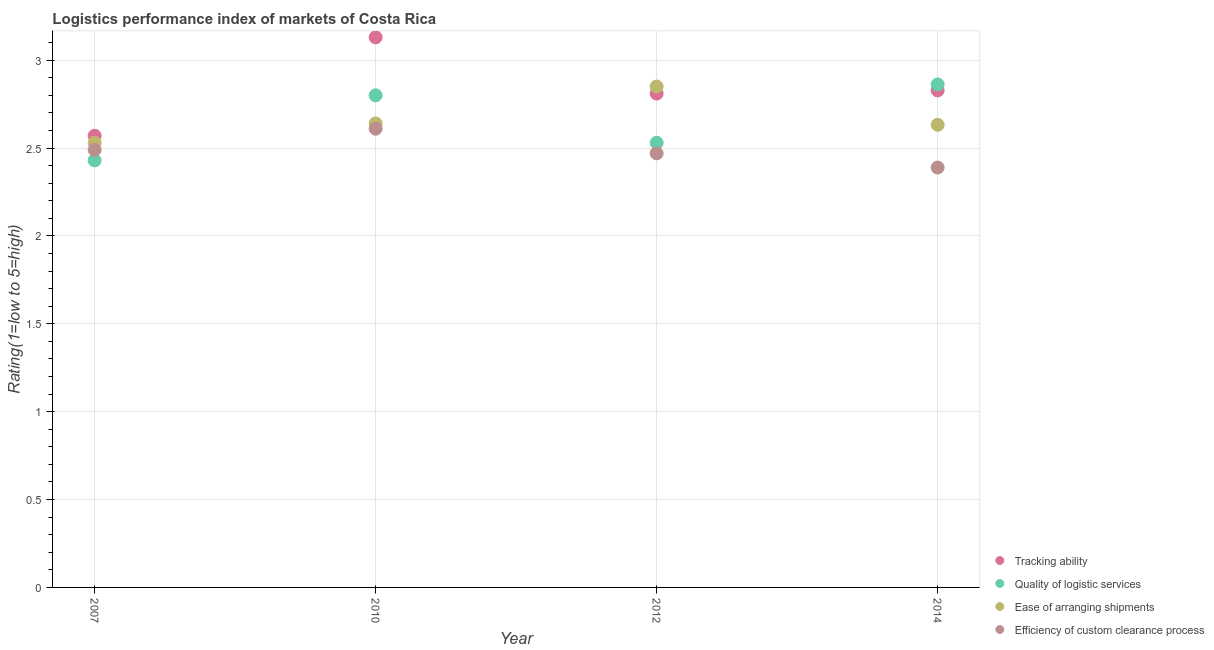What is the lpi rating of tracking ability in 2014?
Give a very brief answer. 2.83. Across all years, what is the maximum lpi rating of quality of logistic services?
Ensure brevity in your answer.  2.86. Across all years, what is the minimum lpi rating of quality of logistic services?
Provide a short and direct response. 2.43. In which year was the lpi rating of tracking ability maximum?
Offer a terse response. 2010. What is the total lpi rating of efficiency of custom clearance process in the graph?
Make the answer very short. 9.96. What is the difference between the lpi rating of efficiency of custom clearance process in 2007 and that in 2010?
Offer a terse response. -0.12. What is the difference between the lpi rating of quality of logistic services in 2010 and the lpi rating of efficiency of custom clearance process in 2014?
Provide a succinct answer. 0.41. What is the average lpi rating of efficiency of custom clearance process per year?
Offer a terse response. 2.49. In the year 2014, what is the difference between the lpi rating of tracking ability and lpi rating of ease of arranging shipments?
Give a very brief answer. 0.2. In how many years, is the lpi rating of tracking ability greater than 1?
Your answer should be compact. 4. What is the ratio of the lpi rating of efficiency of custom clearance process in 2007 to that in 2012?
Ensure brevity in your answer.  1.01. Is the lpi rating of quality of logistic services in 2012 less than that in 2014?
Ensure brevity in your answer.  Yes. What is the difference between the highest and the second highest lpi rating of tracking ability?
Your answer should be compact. 0.3. What is the difference between the highest and the lowest lpi rating of quality of logistic services?
Offer a very short reply. 0.43. Is the lpi rating of tracking ability strictly greater than the lpi rating of ease of arranging shipments over the years?
Offer a very short reply. No. How many dotlines are there?
Keep it short and to the point. 4. How many years are there in the graph?
Keep it short and to the point. 4. What is the difference between two consecutive major ticks on the Y-axis?
Your response must be concise. 0.5. Are the values on the major ticks of Y-axis written in scientific E-notation?
Give a very brief answer. No. Does the graph contain any zero values?
Make the answer very short. No. Where does the legend appear in the graph?
Your answer should be very brief. Bottom right. What is the title of the graph?
Your answer should be compact. Logistics performance index of markets of Costa Rica. What is the label or title of the Y-axis?
Offer a very short reply. Rating(1=low to 5=high). What is the Rating(1=low to 5=high) in Tracking ability in 2007?
Provide a short and direct response. 2.57. What is the Rating(1=low to 5=high) in Quality of logistic services in 2007?
Offer a very short reply. 2.43. What is the Rating(1=low to 5=high) of Ease of arranging shipments in 2007?
Keep it short and to the point. 2.53. What is the Rating(1=low to 5=high) of Efficiency of custom clearance process in 2007?
Your response must be concise. 2.49. What is the Rating(1=low to 5=high) in Tracking ability in 2010?
Your response must be concise. 3.13. What is the Rating(1=low to 5=high) in Ease of arranging shipments in 2010?
Your answer should be compact. 2.64. What is the Rating(1=low to 5=high) in Efficiency of custom clearance process in 2010?
Offer a terse response. 2.61. What is the Rating(1=low to 5=high) of Tracking ability in 2012?
Provide a succinct answer. 2.81. What is the Rating(1=low to 5=high) in Quality of logistic services in 2012?
Provide a succinct answer. 2.53. What is the Rating(1=low to 5=high) of Ease of arranging shipments in 2012?
Offer a very short reply. 2.85. What is the Rating(1=low to 5=high) of Efficiency of custom clearance process in 2012?
Offer a terse response. 2.47. What is the Rating(1=low to 5=high) of Tracking ability in 2014?
Keep it short and to the point. 2.83. What is the Rating(1=low to 5=high) in Quality of logistic services in 2014?
Offer a terse response. 2.86. What is the Rating(1=low to 5=high) of Ease of arranging shipments in 2014?
Your answer should be compact. 2.63. What is the Rating(1=low to 5=high) in Efficiency of custom clearance process in 2014?
Offer a terse response. 2.39. Across all years, what is the maximum Rating(1=low to 5=high) in Tracking ability?
Provide a short and direct response. 3.13. Across all years, what is the maximum Rating(1=low to 5=high) in Quality of logistic services?
Your answer should be compact. 2.86. Across all years, what is the maximum Rating(1=low to 5=high) in Ease of arranging shipments?
Offer a terse response. 2.85. Across all years, what is the maximum Rating(1=low to 5=high) in Efficiency of custom clearance process?
Your answer should be compact. 2.61. Across all years, what is the minimum Rating(1=low to 5=high) in Tracking ability?
Ensure brevity in your answer.  2.57. Across all years, what is the minimum Rating(1=low to 5=high) in Quality of logistic services?
Your answer should be compact. 2.43. Across all years, what is the minimum Rating(1=low to 5=high) in Ease of arranging shipments?
Your answer should be compact. 2.53. Across all years, what is the minimum Rating(1=low to 5=high) of Efficiency of custom clearance process?
Provide a succinct answer. 2.39. What is the total Rating(1=low to 5=high) in Tracking ability in the graph?
Make the answer very short. 11.34. What is the total Rating(1=low to 5=high) of Quality of logistic services in the graph?
Your answer should be very brief. 10.62. What is the total Rating(1=low to 5=high) of Ease of arranging shipments in the graph?
Offer a terse response. 10.65. What is the total Rating(1=low to 5=high) in Efficiency of custom clearance process in the graph?
Keep it short and to the point. 9.96. What is the difference between the Rating(1=low to 5=high) in Tracking ability in 2007 and that in 2010?
Provide a succinct answer. -0.56. What is the difference between the Rating(1=low to 5=high) in Quality of logistic services in 2007 and that in 2010?
Make the answer very short. -0.37. What is the difference between the Rating(1=low to 5=high) of Ease of arranging shipments in 2007 and that in 2010?
Offer a very short reply. -0.11. What is the difference between the Rating(1=low to 5=high) of Efficiency of custom clearance process in 2007 and that in 2010?
Keep it short and to the point. -0.12. What is the difference between the Rating(1=low to 5=high) in Tracking ability in 2007 and that in 2012?
Your response must be concise. -0.24. What is the difference between the Rating(1=low to 5=high) of Ease of arranging shipments in 2007 and that in 2012?
Give a very brief answer. -0.32. What is the difference between the Rating(1=low to 5=high) of Tracking ability in 2007 and that in 2014?
Make the answer very short. -0.26. What is the difference between the Rating(1=low to 5=high) in Quality of logistic services in 2007 and that in 2014?
Ensure brevity in your answer.  -0.43. What is the difference between the Rating(1=low to 5=high) in Ease of arranging shipments in 2007 and that in 2014?
Make the answer very short. -0.1. What is the difference between the Rating(1=low to 5=high) of Efficiency of custom clearance process in 2007 and that in 2014?
Provide a short and direct response. 0.1. What is the difference between the Rating(1=low to 5=high) of Tracking ability in 2010 and that in 2012?
Make the answer very short. 0.32. What is the difference between the Rating(1=low to 5=high) of Quality of logistic services in 2010 and that in 2012?
Offer a very short reply. 0.27. What is the difference between the Rating(1=low to 5=high) of Ease of arranging shipments in 2010 and that in 2012?
Your answer should be very brief. -0.21. What is the difference between the Rating(1=low to 5=high) in Efficiency of custom clearance process in 2010 and that in 2012?
Offer a very short reply. 0.14. What is the difference between the Rating(1=low to 5=high) of Tracking ability in 2010 and that in 2014?
Your response must be concise. 0.3. What is the difference between the Rating(1=low to 5=high) in Quality of logistic services in 2010 and that in 2014?
Your answer should be very brief. -0.06. What is the difference between the Rating(1=low to 5=high) of Ease of arranging shipments in 2010 and that in 2014?
Your answer should be very brief. 0.01. What is the difference between the Rating(1=low to 5=high) of Efficiency of custom clearance process in 2010 and that in 2014?
Offer a very short reply. 0.22. What is the difference between the Rating(1=low to 5=high) of Tracking ability in 2012 and that in 2014?
Give a very brief answer. -0.02. What is the difference between the Rating(1=low to 5=high) in Quality of logistic services in 2012 and that in 2014?
Offer a terse response. -0.33. What is the difference between the Rating(1=low to 5=high) in Ease of arranging shipments in 2012 and that in 2014?
Your answer should be compact. 0.22. What is the difference between the Rating(1=low to 5=high) in Efficiency of custom clearance process in 2012 and that in 2014?
Your answer should be compact. 0.08. What is the difference between the Rating(1=low to 5=high) in Tracking ability in 2007 and the Rating(1=low to 5=high) in Quality of logistic services in 2010?
Your answer should be very brief. -0.23. What is the difference between the Rating(1=low to 5=high) of Tracking ability in 2007 and the Rating(1=low to 5=high) of Ease of arranging shipments in 2010?
Make the answer very short. -0.07. What is the difference between the Rating(1=low to 5=high) of Tracking ability in 2007 and the Rating(1=low to 5=high) of Efficiency of custom clearance process in 2010?
Your answer should be compact. -0.04. What is the difference between the Rating(1=low to 5=high) of Quality of logistic services in 2007 and the Rating(1=low to 5=high) of Ease of arranging shipments in 2010?
Your answer should be very brief. -0.21. What is the difference between the Rating(1=low to 5=high) of Quality of logistic services in 2007 and the Rating(1=low to 5=high) of Efficiency of custom clearance process in 2010?
Give a very brief answer. -0.18. What is the difference between the Rating(1=low to 5=high) of Ease of arranging shipments in 2007 and the Rating(1=low to 5=high) of Efficiency of custom clearance process in 2010?
Your response must be concise. -0.08. What is the difference between the Rating(1=low to 5=high) in Tracking ability in 2007 and the Rating(1=low to 5=high) in Quality of logistic services in 2012?
Ensure brevity in your answer.  0.04. What is the difference between the Rating(1=low to 5=high) in Tracking ability in 2007 and the Rating(1=low to 5=high) in Ease of arranging shipments in 2012?
Your answer should be very brief. -0.28. What is the difference between the Rating(1=low to 5=high) in Tracking ability in 2007 and the Rating(1=low to 5=high) in Efficiency of custom clearance process in 2012?
Offer a terse response. 0.1. What is the difference between the Rating(1=low to 5=high) of Quality of logistic services in 2007 and the Rating(1=low to 5=high) of Ease of arranging shipments in 2012?
Give a very brief answer. -0.42. What is the difference between the Rating(1=low to 5=high) of Quality of logistic services in 2007 and the Rating(1=low to 5=high) of Efficiency of custom clearance process in 2012?
Ensure brevity in your answer.  -0.04. What is the difference between the Rating(1=low to 5=high) in Ease of arranging shipments in 2007 and the Rating(1=low to 5=high) in Efficiency of custom clearance process in 2012?
Offer a very short reply. 0.06. What is the difference between the Rating(1=low to 5=high) in Tracking ability in 2007 and the Rating(1=low to 5=high) in Quality of logistic services in 2014?
Make the answer very short. -0.29. What is the difference between the Rating(1=low to 5=high) in Tracking ability in 2007 and the Rating(1=low to 5=high) in Ease of arranging shipments in 2014?
Offer a very short reply. -0.06. What is the difference between the Rating(1=low to 5=high) in Tracking ability in 2007 and the Rating(1=low to 5=high) in Efficiency of custom clearance process in 2014?
Provide a succinct answer. 0.18. What is the difference between the Rating(1=low to 5=high) of Quality of logistic services in 2007 and the Rating(1=low to 5=high) of Ease of arranging shipments in 2014?
Give a very brief answer. -0.2. What is the difference between the Rating(1=low to 5=high) of Quality of logistic services in 2007 and the Rating(1=low to 5=high) of Efficiency of custom clearance process in 2014?
Give a very brief answer. 0.04. What is the difference between the Rating(1=low to 5=high) in Ease of arranging shipments in 2007 and the Rating(1=low to 5=high) in Efficiency of custom clearance process in 2014?
Offer a terse response. 0.14. What is the difference between the Rating(1=low to 5=high) of Tracking ability in 2010 and the Rating(1=low to 5=high) of Quality of logistic services in 2012?
Your answer should be compact. 0.6. What is the difference between the Rating(1=low to 5=high) in Tracking ability in 2010 and the Rating(1=low to 5=high) in Ease of arranging shipments in 2012?
Your answer should be very brief. 0.28. What is the difference between the Rating(1=low to 5=high) of Tracking ability in 2010 and the Rating(1=low to 5=high) of Efficiency of custom clearance process in 2012?
Provide a succinct answer. 0.66. What is the difference between the Rating(1=low to 5=high) of Quality of logistic services in 2010 and the Rating(1=low to 5=high) of Efficiency of custom clearance process in 2012?
Provide a succinct answer. 0.33. What is the difference between the Rating(1=low to 5=high) in Ease of arranging shipments in 2010 and the Rating(1=low to 5=high) in Efficiency of custom clearance process in 2012?
Provide a short and direct response. 0.17. What is the difference between the Rating(1=low to 5=high) in Tracking ability in 2010 and the Rating(1=low to 5=high) in Quality of logistic services in 2014?
Offer a very short reply. 0.27. What is the difference between the Rating(1=low to 5=high) of Tracking ability in 2010 and the Rating(1=low to 5=high) of Ease of arranging shipments in 2014?
Offer a terse response. 0.5. What is the difference between the Rating(1=low to 5=high) of Tracking ability in 2010 and the Rating(1=low to 5=high) of Efficiency of custom clearance process in 2014?
Give a very brief answer. 0.74. What is the difference between the Rating(1=low to 5=high) of Quality of logistic services in 2010 and the Rating(1=low to 5=high) of Ease of arranging shipments in 2014?
Keep it short and to the point. 0.17. What is the difference between the Rating(1=low to 5=high) of Quality of logistic services in 2010 and the Rating(1=low to 5=high) of Efficiency of custom clearance process in 2014?
Keep it short and to the point. 0.41. What is the difference between the Rating(1=low to 5=high) in Ease of arranging shipments in 2010 and the Rating(1=low to 5=high) in Efficiency of custom clearance process in 2014?
Give a very brief answer. 0.25. What is the difference between the Rating(1=low to 5=high) of Tracking ability in 2012 and the Rating(1=low to 5=high) of Quality of logistic services in 2014?
Provide a short and direct response. -0.05. What is the difference between the Rating(1=low to 5=high) of Tracking ability in 2012 and the Rating(1=low to 5=high) of Ease of arranging shipments in 2014?
Offer a very short reply. 0.18. What is the difference between the Rating(1=low to 5=high) of Tracking ability in 2012 and the Rating(1=low to 5=high) of Efficiency of custom clearance process in 2014?
Offer a very short reply. 0.42. What is the difference between the Rating(1=low to 5=high) of Quality of logistic services in 2012 and the Rating(1=low to 5=high) of Ease of arranging shipments in 2014?
Provide a short and direct response. -0.1. What is the difference between the Rating(1=low to 5=high) of Quality of logistic services in 2012 and the Rating(1=low to 5=high) of Efficiency of custom clearance process in 2014?
Your answer should be compact. 0.14. What is the difference between the Rating(1=low to 5=high) in Ease of arranging shipments in 2012 and the Rating(1=low to 5=high) in Efficiency of custom clearance process in 2014?
Give a very brief answer. 0.46. What is the average Rating(1=low to 5=high) in Tracking ability per year?
Provide a short and direct response. 2.83. What is the average Rating(1=low to 5=high) in Quality of logistic services per year?
Your response must be concise. 2.66. What is the average Rating(1=low to 5=high) of Ease of arranging shipments per year?
Your response must be concise. 2.66. What is the average Rating(1=low to 5=high) in Efficiency of custom clearance process per year?
Your response must be concise. 2.49. In the year 2007, what is the difference between the Rating(1=low to 5=high) in Tracking ability and Rating(1=low to 5=high) in Quality of logistic services?
Your answer should be very brief. 0.14. In the year 2007, what is the difference between the Rating(1=low to 5=high) of Quality of logistic services and Rating(1=low to 5=high) of Ease of arranging shipments?
Keep it short and to the point. -0.1. In the year 2007, what is the difference between the Rating(1=low to 5=high) in Quality of logistic services and Rating(1=low to 5=high) in Efficiency of custom clearance process?
Keep it short and to the point. -0.06. In the year 2010, what is the difference between the Rating(1=low to 5=high) of Tracking ability and Rating(1=low to 5=high) of Quality of logistic services?
Provide a succinct answer. 0.33. In the year 2010, what is the difference between the Rating(1=low to 5=high) in Tracking ability and Rating(1=low to 5=high) in Ease of arranging shipments?
Your response must be concise. 0.49. In the year 2010, what is the difference between the Rating(1=low to 5=high) of Tracking ability and Rating(1=low to 5=high) of Efficiency of custom clearance process?
Your answer should be compact. 0.52. In the year 2010, what is the difference between the Rating(1=low to 5=high) of Quality of logistic services and Rating(1=low to 5=high) of Ease of arranging shipments?
Provide a succinct answer. 0.16. In the year 2010, what is the difference between the Rating(1=low to 5=high) of Quality of logistic services and Rating(1=low to 5=high) of Efficiency of custom clearance process?
Your answer should be very brief. 0.19. In the year 2012, what is the difference between the Rating(1=low to 5=high) in Tracking ability and Rating(1=low to 5=high) in Quality of logistic services?
Make the answer very short. 0.28. In the year 2012, what is the difference between the Rating(1=low to 5=high) in Tracking ability and Rating(1=low to 5=high) in Ease of arranging shipments?
Offer a terse response. -0.04. In the year 2012, what is the difference between the Rating(1=low to 5=high) in Tracking ability and Rating(1=low to 5=high) in Efficiency of custom clearance process?
Offer a very short reply. 0.34. In the year 2012, what is the difference between the Rating(1=low to 5=high) of Quality of logistic services and Rating(1=low to 5=high) of Ease of arranging shipments?
Offer a terse response. -0.32. In the year 2012, what is the difference between the Rating(1=low to 5=high) in Ease of arranging shipments and Rating(1=low to 5=high) in Efficiency of custom clearance process?
Make the answer very short. 0.38. In the year 2014, what is the difference between the Rating(1=low to 5=high) of Tracking ability and Rating(1=low to 5=high) of Quality of logistic services?
Provide a succinct answer. -0.03. In the year 2014, what is the difference between the Rating(1=low to 5=high) in Tracking ability and Rating(1=low to 5=high) in Ease of arranging shipments?
Offer a terse response. 0.2. In the year 2014, what is the difference between the Rating(1=low to 5=high) of Tracking ability and Rating(1=low to 5=high) of Efficiency of custom clearance process?
Make the answer very short. 0.44. In the year 2014, what is the difference between the Rating(1=low to 5=high) of Quality of logistic services and Rating(1=low to 5=high) of Ease of arranging shipments?
Keep it short and to the point. 0.23. In the year 2014, what is the difference between the Rating(1=low to 5=high) in Quality of logistic services and Rating(1=low to 5=high) in Efficiency of custom clearance process?
Make the answer very short. 0.47. In the year 2014, what is the difference between the Rating(1=low to 5=high) of Ease of arranging shipments and Rating(1=low to 5=high) of Efficiency of custom clearance process?
Offer a very short reply. 0.24. What is the ratio of the Rating(1=low to 5=high) of Tracking ability in 2007 to that in 2010?
Offer a terse response. 0.82. What is the ratio of the Rating(1=low to 5=high) in Quality of logistic services in 2007 to that in 2010?
Provide a succinct answer. 0.87. What is the ratio of the Rating(1=low to 5=high) in Ease of arranging shipments in 2007 to that in 2010?
Provide a short and direct response. 0.96. What is the ratio of the Rating(1=low to 5=high) of Efficiency of custom clearance process in 2007 to that in 2010?
Offer a terse response. 0.95. What is the ratio of the Rating(1=low to 5=high) in Tracking ability in 2007 to that in 2012?
Keep it short and to the point. 0.91. What is the ratio of the Rating(1=low to 5=high) in Quality of logistic services in 2007 to that in 2012?
Give a very brief answer. 0.96. What is the ratio of the Rating(1=low to 5=high) in Ease of arranging shipments in 2007 to that in 2012?
Provide a succinct answer. 0.89. What is the ratio of the Rating(1=low to 5=high) of Tracking ability in 2007 to that in 2014?
Your answer should be very brief. 0.91. What is the ratio of the Rating(1=low to 5=high) of Quality of logistic services in 2007 to that in 2014?
Provide a succinct answer. 0.85. What is the ratio of the Rating(1=low to 5=high) in Ease of arranging shipments in 2007 to that in 2014?
Offer a terse response. 0.96. What is the ratio of the Rating(1=low to 5=high) of Efficiency of custom clearance process in 2007 to that in 2014?
Your answer should be compact. 1.04. What is the ratio of the Rating(1=low to 5=high) in Tracking ability in 2010 to that in 2012?
Your answer should be very brief. 1.11. What is the ratio of the Rating(1=low to 5=high) in Quality of logistic services in 2010 to that in 2012?
Give a very brief answer. 1.11. What is the ratio of the Rating(1=low to 5=high) of Ease of arranging shipments in 2010 to that in 2012?
Your response must be concise. 0.93. What is the ratio of the Rating(1=low to 5=high) of Efficiency of custom clearance process in 2010 to that in 2012?
Keep it short and to the point. 1.06. What is the ratio of the Rating(1=low to 5=high) in Tracking ability in 2010 to that in 2014?
Provide a short and direct response. 1.11. What is the ratio of the Rating(1=low to 5=high) in Quality of logistic services in 2010 to that in 2014?
Offer a terse response. 0.98. What is the ratio of the Rating(1=low to 5=high) in Ease of arranging shipments in 2010 to that in 2014?
Your response must be concise. 1. What is the ratio of the Rating(1=low to 5=high) in Efficiency of custom clearance process in 2010 to that in 2014?
Provide a short and direct response. 1.09. What is the ratio of the Rating(1=low to 5=high) in Tracking ability in 2012 to that in 2014?
Ensure brevity in your answer.  0.99. What is the ratio of the Rating(1=low to 5=high) in Quality of logistic services in 2012 to that in 2014?
Keep it short and to the point. 0.88. What is the ratio of the Rating(1=low to 5=high) in Ease of arranging shipments in 2012 to that in 2014?
Keep it short and to the point. 1.08. What is the ratio of the Rating(1=low to 5=high) in Efficiency of custom clearance process in 2012 to that in 2014?
Your response must be concise. 1.03. What is the difference between the highest and the second highest Rating(1=low to 5=high) of Tracking ability?
Ensure brevity in your answer.  0.3. What is the difference between the highest and the second highest Rating(1=low to 5=high) in Quality of logistic services?
Your response must be concise. 0.06. What is the difference between the highest and the second highest Rating(1=low to 5=high) in Ease of arranging shipments?
Offer a terse response. 0.21. What is the difference between the highest and the second highest Rating(1=low to 5=high) in Efficiency of custom clearance process?
Keep it short and to the point. 0.12. What is the difference between the highest and the lowest Rating(1=low to 5=high) in Tracking ability?
Provide a short and direct response. 0.56. What is the difference between the highest and the lowest Rating(1=low to 5=high) in Quality of logistic services?
Ensure brevity in your answer.  0.43. What is the difference between the highest and the lowest Rating(1=low to 5=high) of Ease of arranging shipments?
Offer a very short reply. 0.32. What is the difference between the highest and the lowest Rating(1=low to 5=high) of Efficiency of custom clearance process?
Provide a succinct answer. 0.22. 